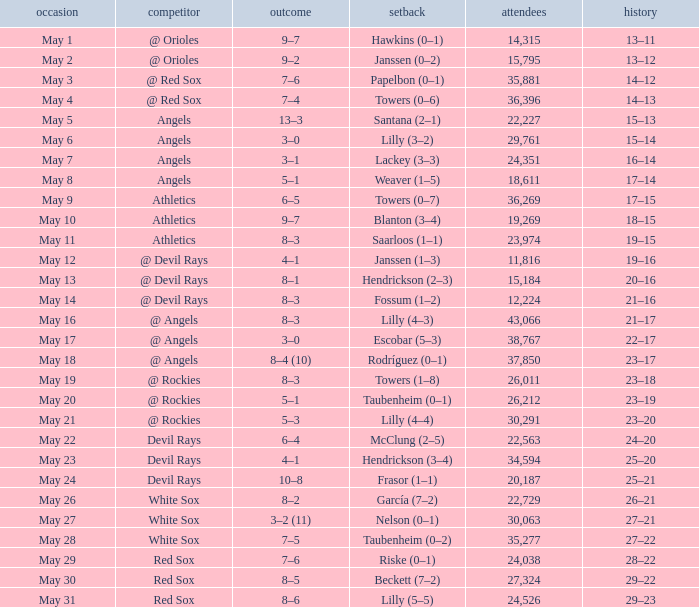When the team had their record of 16–14, what was the total attendance? 1.0. Could you parse the entire table as a dict? {'header': ['occasion', 'competitor', 'outcome', 'setback', 'attendees', 'history'], 'rows': [['May 1', '@ Orioles', '9–7', 'Hawkins (0–1)', '14,315', '13–11'], ['May 2', '@ Orioles', '9–2', 'Janssen (0–2)', '15,795', '13–12'], ['May 3', '@ Red Sox', '7–6', 'Papelbon (0–1)', '35,881', '14–12'], ['May 4', '@ Red Sox', '7–4', 'Towers (0–6)', '36,396', '14–13'], ['May 5', 'Angels', '13–3', 'Santana (2–1)', '22,227', '15–13'], ['May 6', 'Angels', '3–0', 'Lilly (3–2)', '29,761', '15–14'], ['May 7', 'Angels', '3–1', 'Lackey (3–3)', '24,351', '16–14'], ['May 8', 'Angels', '5–1', 'Weaver (1–5)', '18,611', '17–14'], ['May 9', 'Athletics', '6–5', 'Towers (0–7)', '36,269', '17–15'], ['May 10', 'Athletics', '9–7', 'Blanton (3–4)', '19,269', '18–15'], ['May 11', 'Athletics', '8–3', 'Saarloos (1–1)', '23,974', '19–15'], ['May 12', '@ Devil Rays', '4–1', 'Janssen (1–3)', '11,816', '19–16'], ['May 13', '@ Devil Rays', '8–1', 'Hendrickson (2–3)', '15,184', '20–16'], ['May 14', '@ Devil Rays', '8–3', 'Fossum (1–2)', '12,224', '21–16'], ['May 16', '@ Angels', '8–3', 'Lilly (4–3)', '43,066', '21–17'], ['May 17', '@ Angels', '3–0', 'Escobar (5–3)', '38,767', '22–17'], ['May 18', '@ Angels', '8–4 (10)', 'Rodríguez (0–1)', '37,850', '23–17'], ['May 19', '@ Rockies', '8–3', 'Towers (1–8)', '26,011', '23–18'], ['May 20', '@ Rockies', '5–1', 'Taubenheim (0–1)', '26,212', '23–19'], ['May 21', '@ Rockies', '5–3', 'Lilly (4–4)', '30,291', '23–20'], ['May 22', 'Devil Rays', '6–4', 'McClung (2–5)', '22,563', '24–20'], ['May 23', 'Devil Rays', '4–1', 'Hendrickson (3–4)', '34,594', '25–20'], ['May 24', 'Devil Rays', '10–8', 'Frasor (1–1)', '20,187', '25–21'], ['May 26', 'White Sox', '8–2', 'García (7–2)', '22,729', '26–21'], ['May 27', 'White Sox', '3–2 (11)', 'Nelson (0–1)', '30,063', '27–21'], ['May 28', 'White Sox', '7–5', 'Taubenheim (0–2)', '35,277', '27–22'], ['May 29', 'Red Sox', '7–6', 'Riske (0–1)', '24,038', '28–22'], ['May 30', 'Red Sox', '8–5', 'Beckett (7–2)', '27,324', '29–22'], ['May 31', 'Red Sox', '8–6', 'Lilly (5–5)', '24,526', '29–23']]} 